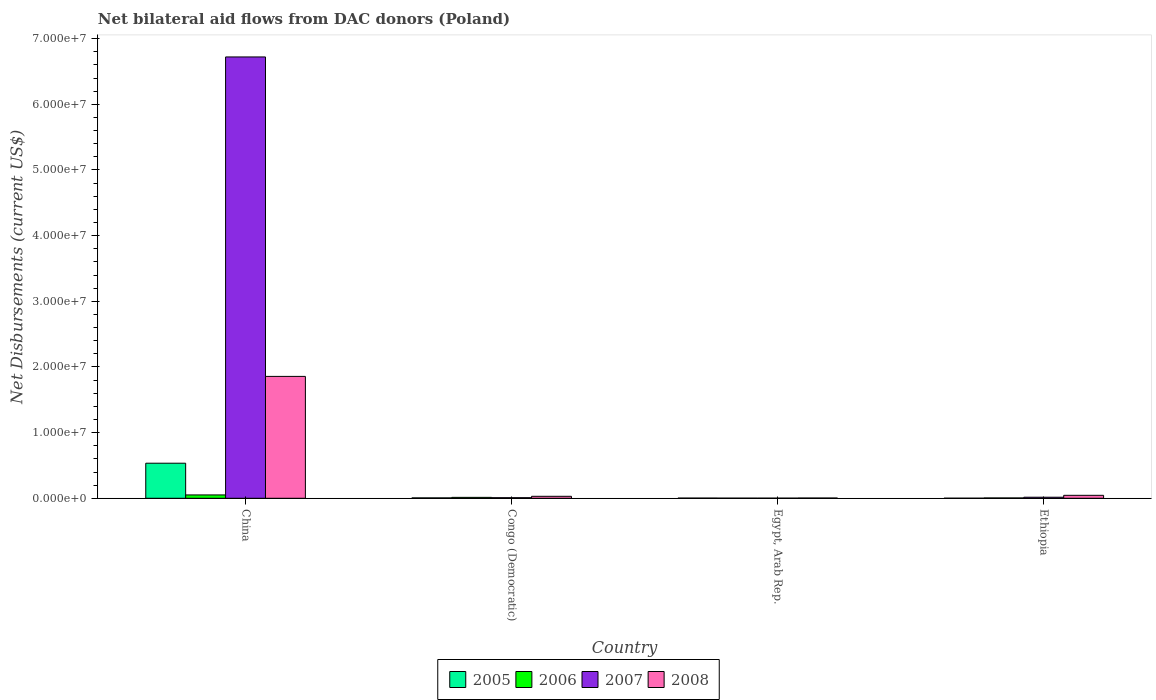How many different coloured bars are there?
Make the answer very short. 4. Are the number of bars per tick equal to the number of legend labels?
Your response must be concise. Yes. Are the number of bars on each tick of the X-axis equal?
Your response must be concise. Yes. How many bars are there on the 4th tick from the left?
Offer a terse response. 4. What is the label of the 1st group of bars from the left?
Offer a terse response. China. What is the net bilateral aid flows in 2006 in China?
Your answer should be very brief. 5.10e+05. Across all countries, what is the maximum net bilateral aid flows in 2007?
Make the answer very short. 6.72e+07. Across all countries, what is the minimum net bilateral aid flows in 2007?
Your answer should be very brief. 2.00e+04. In which country was the net bilateral aid flows in 2005 minimum?
Your response must be concise. Ethiopia. What is the total net bilateral aid flows in 2006 in the graph?
Give a very brief answer. 7.20e+05. What is the difference between the net bilateral aid flows in 2008 in China and that in Congo (Democratic)?
Keep it short and to the point. 1.83e+07. What is the difference between the net bilateral aid flows in 2005 in Congo (Democratic) and the net bilateral aid flows in 2008 in China?
Offer a very short reply. -1.85e+07. What is the average net bilateral aid flows in 2008 per country?
Give a very brief answer. 4.84e+06. In how many countries, is the net bilateral aid flows in 2006 greater than 4000000 US$?
Ensure brevity in your answer.  0. What is the ratio of the net bilateral aid flows in 2008 in Egypt, Arab Rep. to that in Ethiopia?
Your answer should be very brief. 0.09. Is the net bilateral aid flows in 2007 in Egypt, Arab Rep. less than that in Ethiopia?
Your answer should be very brief. Yes. Is the difference between the net bilateral aid flows in 2005 in China and Egypt, Arab Rep. greater than the difference between the net bilateral aid flows in 2007 in China and Egypt, Arab Rep.?
Ensure brevity in your answer.  No. What is the difference between the highest and the second highest net bilateral aid flows in 2008?
Offer a very short reply. 1.83e+07. What is the difference between the highest and the lowest net bilateral aid flows in 2008?
Your answer should be very brief. 1.85e+07. In how many countries, is the net bilateral aid flows in 2008 greater than the average net bilateral aid flows in 2008 taken over all countries?
Offer a terse response. 1. Is the sum of the net bilateral aid flows in 2005 in China and Ethiopia greater than the maximum net bilateral aid flows in 2007 across all countries?
Ensure brevity in your answer.  No. Is it the case that in every country, the sum of the net bilateral aid flows in 2007 and net bilateral aid flows in 2008 is greater than the sum of net bilateral aid flows in 2006 and net bilateral aid flows in 2005?
Keep it short and to the point. No. What does the 4th bar from the left in China represents?
Provide a short and direct response. 2008. Is it the case that in every country, the sum of the net bilateral aid flows in 2007 and net bilateral aid flows in 2005 is greater than the net bilateral aid flows in 2006?
Give a very brief answer. Yes. How many legend labels are there?
Provide a short and direct response. 4. How are the legend labels stacked?
Provide a short and direct response. Horizontal. What is the title of the graph?
Make the answer very short. Net bilateral aid flows from DAC donors (Poland). Does "1993" appear as one of the legend labels in the graph?
Offer a very short reply. No. What is the label or title of the Y-axis?
Provide a short and direct response. Net Disbursements (current US$). What is the Net Disbursements (current US$) of 2005 in China?
Your answer should be very brief. 5.34e+06. What is the Net Disbursements (current US$) in 2006 in China?
Offer a very short reply. 5.10e+05. What is the Net Disbursements (current US$) in 2007 in China?
Ensure brevity in your answer.  6.72e+07. What is the Net Disbursements (current US$) of 2008 in China?
Offer a terse response. 1.86e+07. What is the Net Disbursements (current US$) of 2005 in Congo (Democratic)?
Keep it short and to the point. 6.00e+04. What is the Net Disbursements (current US$) of 2007 in Congo (Democratic)?
Offer a very short reply. 9.00e+04. What is the Net Disbursements (current US$) of 2005 in Egypt, Arab Rep.?
Offer a terse response. 3.00e+04. What is the Net Disbursements (current US$) of 2006 in Egypt, Arab Rep.?
Offer a very short reply. 2.00e+04. What is the Net Disbursements (current US$) of 2007 in Egypt, Arab Rep.?
Make the answer very short. 2.00e+04. What is the Net Disbursements (current US$) of 2008 in Egypt, Arab Rep.?
Provide a short and direct response. 4.00e+04. What is the Net Disbursements (current US$) of 2007 in Ethiopia?
Offer a very short reply. 1.60e+05. What is the Net Disbursements (current US$) of 2008 in Ethiopia?
Your answer should be very brief. 4.50e+05. Across all countries, what is the maximum Net Disbursements (current US$) in 2005?
Make the answer very short. 5.34e+06. Across all countries, what is the maximum Net Disbursements (current US$) in 2006?
Your answer should be compact. 5.10e+05. Across all countries, what is the maximum Net Disbursements (current US$) in 2007?
Give a very brief answer. 6.72e+07. Across all countries, what is the maximum Net Disbursements (current US$) in 2008?
Make the answer very short. 1.86e+07. Across all countries, what is the minimum Net Disbursements (current US$) in 2008?
Ensure brevity in your answer.  4.00e+04. What is the total Net Disbursements (current US$) in 2005 in the graph?
Make the answer very short. 5.44e+06. What is the total Net Disbursements (current US$) of 2006 in the graph?
Keep it short and to the point. 7.20e+05. What is the total Net Disbursements (current US$) in 2007 in the graph?
Ensure brevity in your answer.  6.75e+07. What is the total Net Disbursements (current US$) of 2008 in the graph?
Provide a short and direct response. 1.94e+07. What is the difference between the Net Disbursements (current US$) in 2005 in China and that in Congo (Democratic)?
Your answer should be very brief. 5.28e+06. What is the difference between the Net Disbursements (current US$) of 2007 in China and that in Congo (Democratic)?
Give a very brief answer. 6.71e+07. What is the difference between the Net Disbursements (current US$) of 2008 in China and that in Congo (Democratic)?
Your answer should be compact. 1.83e+07. What is the difference between the Net Disbursements (current US$) in 2005 in China and that in Egypt, Arab Rep.?
Keep it short and to the point. 5.31e+06. What is the difference between the Net Disbursements (current US$) of 2007 in China and that in Egypt, Arab Rep.?
Give a very brief answer. 6.72e+07. What is the difference between the Net Disbursements (current US$) of 2008 in China and that in Egypt, Arab Rep.?
Your response must be concise. 1.85e+07. What is the difference between the Net Disbursements (current US$) in 2005 in China and that in Ethiopia?
Give a very brief answer. 5.33e+06. What is the difference between the Net Disbursements (current US$) in 2006 in China and that in Ethiopia?
Offer a very short reply. 4.60e+05. What is the difference between the Net Disbursements (current US$) of 2007 in China and that in Ethiopia?
Ensure brevity in your answer.  6.70e+07. What is the difference between the Net Disbursements (current US$) in 2008 in China and that in Ethiopia?
Your answer should be very brief. 1.81e+07. What is the difference between the Net Disbursements (current US$) of 2006 in Congo (Democratic) and that in Egypt, Arab Rep.?
Keep it short and to the point. 1.20e+05. What is the difference between the Net Disbursements (current US$) of 2008 in Congo (Democratic) and that in Egypt, Arab Rep.?
Your answer should be compact. 2.60e+05. What is the difference between the Net Disbursements (current US$) of 2005 in Congo (Democratic) and that in Ethiopia?
Your answer should be compact. 5.00e+04. What is the difference between the Net Disbursements (current US$) of 2006 in Congo (Democratic) and that in Ethiopia?
Provide a succinct answer. 9.00e+04. What is the difference between the Net Disbursements (current US$) of 2006 in Egypt, Arab Rep. and that in Ethiopia?
Offer a very short reply. -3.00e+04. What is the difference between the Net Disbursements (current US$) in 2008 in Egypt, Arab Rep. and that in Ethiopia?
Your answer should be compact. -4.10e+05. What is the difference between the Net Disbursements (current US$) of 2005 in China and the Net Disbursements (current US$) of 2006 in Congo (Democratic)?
Your response must be concise. 5.20e+06. What is the difference between the Net Disbursements (current US$) of 2005 in China and the Net Disbursements (current US$) of 2007 in Congo (Democratic)?
Keep it short and to the point. 5.25e+06. What is the difference between the Net Disbursements (current US$) of 2005 in China and the Net Disbursements (current US$) of 2008 in Congo (Democratic)?
Provide a succinct answer. 5.04e+06. What is the difference between the Net Disbursements (current US$) of 2007 in China and the Net Disbursements (current US$) of 2008 in Congo (Democratic)?
Provide a succinct answer. 6.69e+07. What is the difference between the Net Disbursements (current US$) in 2005 in China and the Net Disbursements (current US$) in 2006 in Egypt, Arab Rep.?
Provide a short and direct response. 5.32e+06. What is the difference between the Net Disbursements (current US$) of 2005 in China and the Net Disbursements (current US$) of 2007 in Egypt, Arab Rep.?
Make the answer very short. 5.32e+06. What is the difference between the Net Disbursements (current US$) in 2005 in China and the Net Disbursements (current US$) in 2008 in Egypt, Arab Rep.?
Keep it short and to the point. 5.30e+06. What is the difference between the Net Disbursements (current US$) of 2006 in China and the Net Disbursements (current US$) of 2007 in Egypt, Arab Rep.?
Give a very brief answer. 4.90e+05. What is the difference between the Net Disbursements (current US$) in 2007 in China and the Net Disbursements (current US$) in 2008 in Egypt, Arab Rep.?
Provide a short and direct response. 6.72e+07. What is the difference between the Net Disbursements (current US$) in 2005 in China and the Net Disbursements (current US$) in 2006 in Ethiopia?
Your answer should be compact. 5.29e+06. What is the difference between the Net Disbursements (current US$) in 2005 in China and the Net Disbursements (current US$) in 2007 in Ethiopia?
Make the answer very short. 5.18e+06. What is the difference between the Net Disbursements (current US$) of 2005 in China and the Net Disbursements (current US$) of 2008 in Ethiopia?
Provide a succinct answer. 4.89e+06. What is the difference between the Net Disbursements (current US$) of 2007 in China and the Net Disbursements (current US$) of 2008 in Ethiopia?
Your answer should be very brief. 6.68e+07. What is the difference between the Net Disbursements (current US$) of 2005 in Congo (Democratic) and the Net Disbursements (current US$) of 2006 in Egypt, Arab Rep.?
Your answer should be very brief. 4.00e+04. What is the difference between the Net Disbursements (current US$) in 2005 in Congo (Democratic) and the Net Disbursements (current US$) in 2008 in Egypt, Arab Rep.?
Your answer should be compact. 2.00e+04. What is the difference between the Net Disbursements (current US$) in 2007 in Congo (Democratic) and the Net Disbursements (current US$) in 2008 in Egypt, Arab Rep.?
Ensure brevity in your answer.  5.00e+04. What is the difference between the Net Disbursements (current US$) of 2005 in Congo (Democratic) and the Net Disbursements (current US$) of 2008 in Ethiopia?
Make the answer very short. -3.90e+05. What is the difference between the Net Disbursements (current US$) of 2006 in Congo (Democratic) and the Net Disbursements (current US$) of 2007 in Ethiopia?
Provide a succinct answer. -2.00e+04. What is the difference between the Net Disbursements (current US$) in 2006 in Congo (Democratic) and the Net Disbursements (current US$) in 2008 in Ethiopia?
Your response must be concise. -3.10e+05. What is the difference between the Net Disbursements (current US$) in 2007 in Congo (Democratic) and the Net Disbursements (current US$) in 2008 in Ethiopia?
Provide a short and direct response. -3.60e+05. What is the difference between the Net Disbursements (current US$) in 2005 in Egypt, Arab Rep. and the Net Disbursements (current US$) in 2006 in Ethiopia?
Offer a terse response. -2.00e+04. What is the difference between the Net Disbursements (current US$) of 2005 in Egypt, Arab Rep. and the Net Disbursements (current US$) of 2007 in Ethiopia?
Your response must be concise. -1.30e+05. What is the difference between the Net Disbursements (current US$) in 2005 in Egypt, Arab Rep. and the Net Disbursements (current US$) in 2008 in Ethiopia?
Offer a very short reply. -4.20e+05. What is the difference between the Net Disbursements (current US$) in 2006 in Egypt, Arab Rep. and the Net Disbursements (current US$) in 2007 in Ethiopia?
Your answer should be very brief. -1.40e+05. What is the difference between the Net Disbursements (current US$) in 2006 in Egypt, Arab Rep. and the Net Disbursements (current US$) in 2008 in Ethiopia?
Give a very brief answer. -4.30e+05. What is the difference between the Net Disbursements (current US$) in 2007 in Egypt, Arab Rep. and the Net Disbursements (current US$) in 2008 in Ethiopia?
Give a very brief answer. -4.30e+05. What is the average Net Disbursements (current US$) in 2005 per country?
Provide a succinct answer. 1.36e+06. What is the average Net Disbursements (current US$) of 2006 per country?
Ensure brevity in your answer.  1.80e+05. What is the average Net Disbursements (current US$) of 2007 per country?
Your answer should be compact. 1.69e+07. What is the average Net Disbursements (current US$) of 2008 per country?
Make the answer very short. 4.84e+06. What is the difference between the Net Disbursements (current US$) of 2005 and Net Disbursements (current US$) of 2006 in China?
Make the answer very short. 4.83e+06. What is the difference between the Net Disbursements (current US$) of 2005 and Net Disbursements (current US$) of 2007 in China?
Your response must be concise. -6.19e+07. What is the difference between the Net Disbursements (current US$) in 2005 and Net Disbursements (current US$) in 2008 in China?
Ensure brevity in your answer.  -1.32e+07. What is the difference between the Net Disbursements (current US$) of 2006 and Net Disbursements (current US$) of 2007 in China?
Ensure brevity in your answer.  -6.67e+07. What is the difference between the Net Disbursements (current US$) in 2006 and Net Disbursements (current US$) in 2008 in China?
Provide a short and direct response. -1.80e+07. What is the difference between the Net Disbursements (current US$) of 2007 and Net Disbursements (current US$) of 2008 in China?
Give a very brief answer. 4.86e+07. What is the difference between the Net Disbursements (current US$) of 2005 and Net Disbursements (current US$) of 2006 in Congo (Democratic)?
Offer a very short reply. -8.00e+04. What is the difference between the Net Disbursements (current US$) of 2005 and Net Disbursements (current US$) of 2007 in Congo (Democratic)?
Provide a succinct answer. -3.00e+04. What is the difference between the Net Disbursements (current US$) in 2005 and Net Disbursements (current US$) in 2008 in Congo (Democratic)?
Ensure brevity in your answer.  -2.40e+05. What is the difference between the Net Disbursements (current US$) in 2006 and Net Disbursements (current US$) in 2007 in Congo (Democratic)?
Make the answer very short. 5.00e+04. What is the difference between the Net Disbursements (current US$) of 2007 and Net Disbursements (current US$) of 2008 in Congo (Democratic)?
Provide a succinct answer. -2.10e+05. What is the difference between the Net Disbursements (current US$) of 2005 and Net Disbursements (current US$) of 2008 in Egypt, Arab Rep.?
Your answer should be very brief. -10000. What is the difference between the Net Disbursements (current US$) in 2006 and Net Disbursements (current US$) in 2007 in Egypt, Arab Rep.?
Give a very brief answer. 0. What is the difference between the Net Disbursements (current US$) in 2007 and Net Disbursements (current US$) in 2008 in Egypt, Arab Rep.?
Provide a succinct answer. -2.00e+04. What is the difference between the Net Disbursements (current US$) in 2005 and Net Disbursements (current US$) in 2006 in Ethiopia?
Provide a short and direct response. -4.00e+04. What is the difference between the Net Disbursements (current US$) of 2005 and Net Disbursements (current US$) of 2007 in Ethiopia?
Keep it short and to the point. -1.50e+05. What is the difference between the Net Disbursements (current US$) of 2005 and Net Disbursements (current US$) of 2008 in Ethiopia?
Provide a short and direct response. -4.40e+05. What is the difference between the Net Disbursements (current US$) in 2006 and Net Disbursements (current US$) in 2007 in Ethiopia?
Give a very brief answer. -1.10e+05. What is the difference between the Net Disbursements (current US$) in 2006 and Net Disbursements (current US$) in 2008 in Ethiopia?
Make the answer very short. -4.00e+05. What is the ratio of the Net Disbursements (current US$) of 2005 in China to that in Congo (Democratic)?
Offer a very short reply. 89. What is the ratio of the Net Disbursements (current US$) of 2006 in China to that in Congo (Democratic)?
Provide a short and direct response. 3.64. What is the ratio of the Net Disbursements (current US$) of 2007 in China to that in Congo (Democratic)?
Make the answer very short. 746.78. What is the ratio of the Net Disbursements (current US$) in 2008 in China to that in Congo (Democratic)?
Your answer should be very brief. 61.87. What is the ratio of the Net Disbursements (current US$) in 2005 in China to that in Egypt, Arab Rep.?
Give a very brief answer. 178. What is the ratio of the Net Disbursements (current US$) of 2006 in China to that in Egypt, Arab Rep.?
Keep it short and to the point. 25.5. What is the ratio of the Net Disbursements (current US$) of 2007 in China to that in Egypt, Arab Rep.?
Your answer should be compact. 3360.5. What is the ratio of the Net Disbursements (current US$) of 2008 in China to that in Egypt, Arab Rep.?
Your answer should be compact. 464. What is the ratio of the Net Disbursements (current US$) in 2005 in China to that in Ethiopia?
Provide a short and direct response. 534. What is the ratio of the Net Disbursements (current US$) in 2006 in China to that in Ethiopia?
Your answer should be very brief. 10.2. What is the ratio of the Net Disbursements (current US$) of 2007 in China to that in Ethiopia?
Offer a terse response. 420.06. What is the ratio of the Net Disbursements (current US$) of 2008 in China to that in Ethiopia?
Keep it short and to the point. 41.24. What is the ratio of the Net Disbursements (current US$) of 2006 in Congo (Democratic) to that in Egypt, Arab Rep.?
Offer a very short reply. 7. What is the ratio of the Net Disbursements (current US$) of 2007 in Congo (Democratic) to that in Egypt, Arab Rep.?
Offer a terse response. 4.5. What is the ratio of the Net Disbursements (current US$) in 2008 in Congo (Democratic) to that in Egypt, Arab Rep.?
Your response must be concise. 7.5. What is the ratio of the Net Disbursements (current US$) in 2005 in Congo (Democratic) to that in Ethiopia?
Offer a very short reply. 6. What is the ratio of the Net Disbursements (current US$) in 2006 in Congo (Democratic) to that in Ethiopia?
Your response must be concise. 2.8. What is the ratio of the Net Disbursements (current US$) in 2007 in Congo (Democratic) to that in Ethiopia?
Offer a very short reply. 0.56. What is the ratio of the Net Disbursements (current US$) of 2008 in Congo (Democratic) to that in Ethiopia?
Ensure brevity in your answer.  0.67. What is the ratio of the Net Disbursements (current US$) of 2006 in Egypt, Arab Rep. to that in Ethiopia?
Your answer should be very brief. 0.4. What is the ratio of the Net Disbursements (current US$) in 2008 in Egypt, Arab Rep. to that in Ethiopia?
Provide a succinct answer. 0.09. What is the difference between the highest and the second highest Net Disbursements (current US$) of 2005?
Give a very brief answer. 5.28e+06. What is the difference between the highest and the second highest Net Disbursements (current US$) of 2007?
Offer a terse response. 6.70e+07. What is the difference between the highest and the second highest Net Disbursements (current US$) in 2008?
Make the answer very short. 1.81e+07. What is the difference between the highest and the lowest Net Disbursements (current US$) in 2005?
Offer a very short reply. 5.33e+06. What is the difference between the highest and the lowest Net Disbursements (current US$) of 2006?
Keep it short and to the point. 4.90e+05. What is the difference between the highest and the lowest Net Disbursements (current US$) in 2007?
Offer a terse response. 6.72e+07. What is the difference between the highest and the lowest Net Disbursements (current US$) of 2008?
Keep it short and to the point. 1.85e+07. 